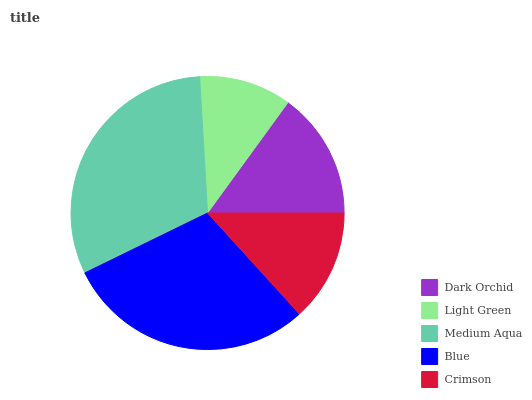Is Light Green the minimum?
Answer yes or no. Yes. Is Medium Aqua the maximum?
Answer yes or no. Yes. Is Medium Aqua the minimum?
Answer yes or no. No. Is Light Green the maximum?
Answer yes or no. No. Is Medium Aqua greater than Light Green?
Answer yes or no. Yes. Is Light Green less than Medium Aqua?
Answer yes or no. Yes. Is Light Green greater than Medium Aqua?
Answer yes or no. No. Is Medium Aqua less than Light Green?
Answer yes or no. No. Is Dark Orchid the high median?
Answer yes or no. Yes. Is Dark Orchid the low median?
Answer yes or no. Yes. Is Medium Aqua the high median?
Answer yes or no. No. Is Light Green the low median?
Answer yes or no. No. 